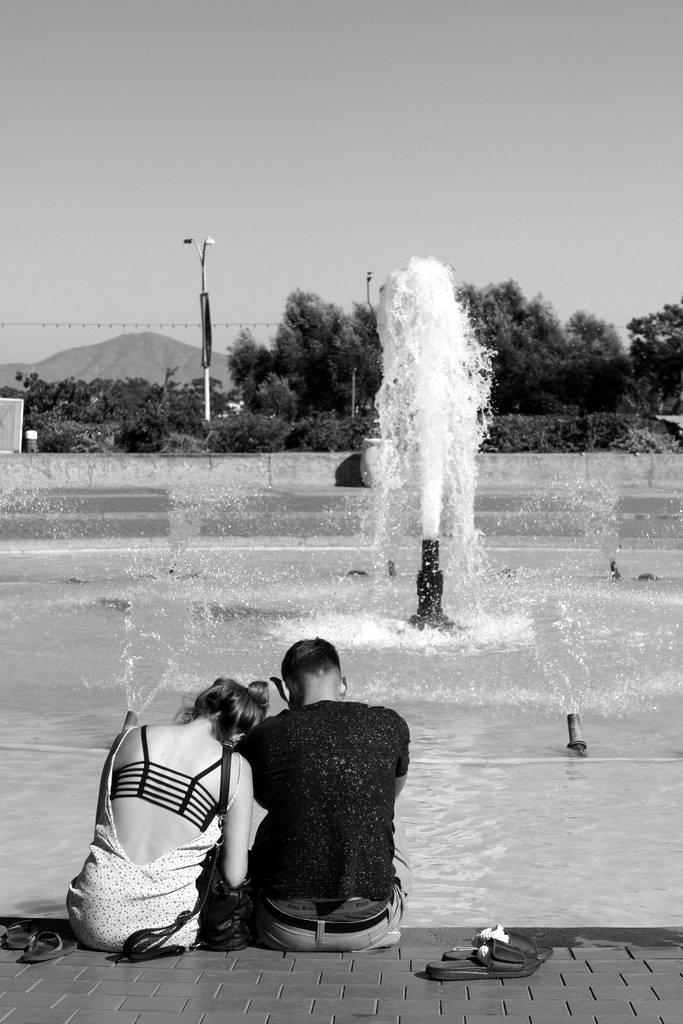Who can be seen in the image? There is a lady and a guy in the image. What are they doing in the image? The lady and the guy are sitting on a path. What else is present near them? There are footwear beside them. What can be seen in the background of the image? There is a water fountain, trees, and plants in the image. Can you describe any other objects in the image? There is a pole in the image. What type of profit can be seen in the image? There is no mention of profit or any financial aspect in the image. The image primarily focuses on the lady, the guy, and their surroundings. 